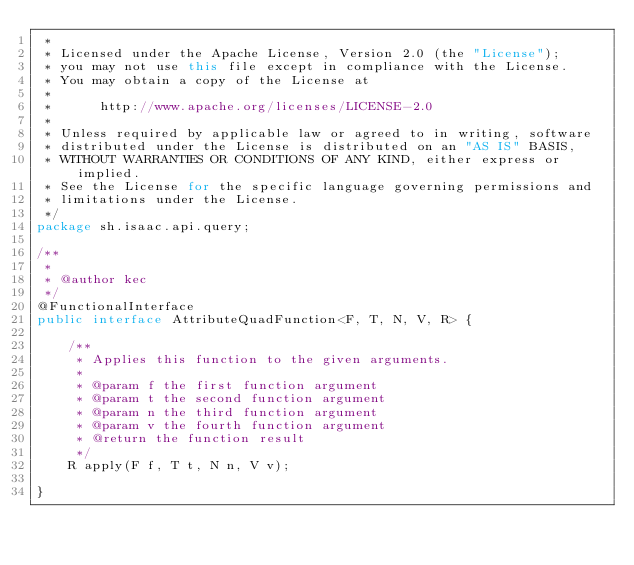<code> <loc_0><loc_0><loc_500><loc_500><_Java_> *
 * Licensed under the Apache License, Version 2.0 (the "License");
 * you may not use this file except in compliance with the License.
 * You may obtain a copy of the License at
 *
 *      http://www.apache.org/licenses/LICENSE-2.0
 *
 * Unless required by applicable law or agreed to in writing, software
 * distributed under the License is distributed on an "AS IS" BASIS,
 * WITHOUT WARRANTIES OR CONDITIONS OF ANY KIND, either express or implied.
 * See the License for the specific language governing permissions and
 * limitations under the License.
 */
package sh.isaac.api.query;

/**
 *
 * @author kec
 */
@FunctionalInterface
public interface AttributeQuadFunction<F, T, N, V, R> {

    /**
     * Applies this function to the given arguments.
     *
     * @param f the first function argument
     * @param t the second function argument
     * @param n the third function argument
     * @param v the fourth function argument
     * @return the function result
     */
    R apply(F f, T t, N n, V v);
    
}
</code> 